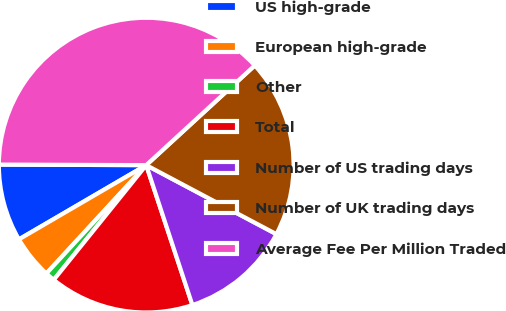Convert chart to OTSL. <chart><loc_0><loc_0><loc_500><loc_500><pie_chart><fcel>US high-grade<fcel>European high-grade<fcel>Other<fcel>Total<fcel>Number of US trading days<fcel>Number of UK trading days<fcel>Average Fee Per Million Traded<nl><fcel>8.46%<fcel>4.75%<fcel>1.05%<fcel>15.87%<fcel>12.17%<fcel>19.58%<fcel>38.12%<nl></chart> 